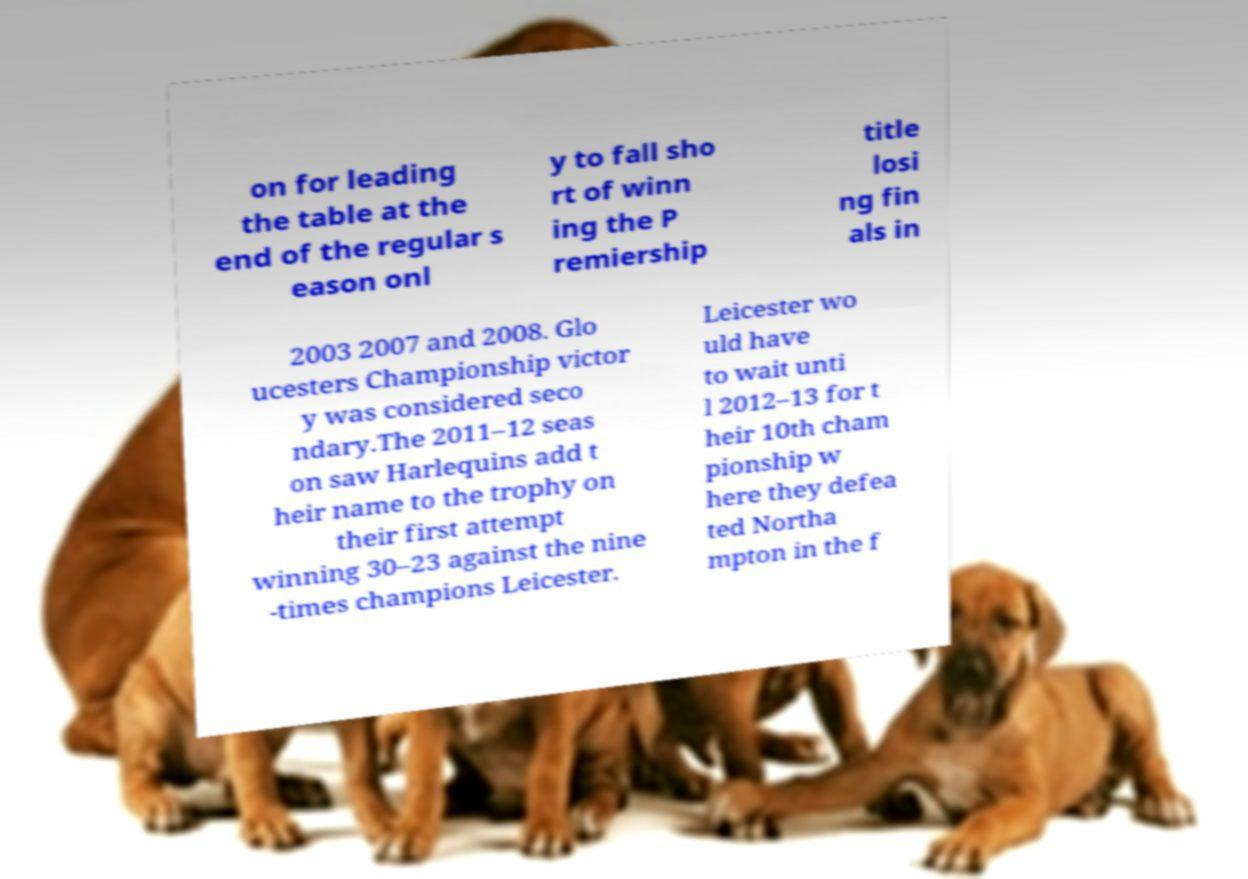Can you read and provide the text displayed in the image?This photo seems to have some interesting text. Can you extract and type it out for me? on for leading the table at the end of the regular s eason onl y to fall sho rt of winn ing the P remiership title losi ng fin als in 2003 2007 and 2008. Glo ucesters Championship victor y was considered seco ndary.The 2011–12 seas on saw Harlequins add t heir name to the trophy on their first attempt winning 30–23 against the nine -times champions Leicester. Leicester wo uld have to wait unti l 2012–13 for t heir 10th cham pionship w here they defea ted Northa mpton in the f 